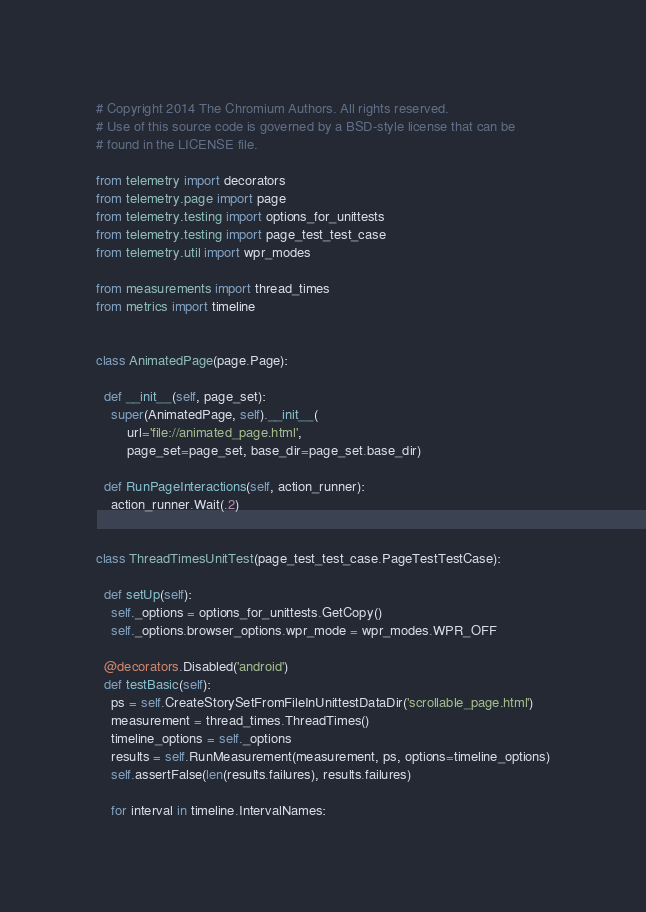Convert code to text. <code><loc_0><loc_0><loc_500><loc_500><_Python_># Copyright 2014 The Chromium Authors. All rights reserved.
# Use of this source code is governed by a BSD-style license that can be
# found in the LICENSE file.

from telemetry import decorators
from telemetry.page import page
from telemetry.testing import options_for_unittests
from telemetry.testing import page_test_test_case
from telemetry.util import wpr_modes

from measurements import thread_times
from metrics import timeline


class AnimatedPage(page.Page):

  def __init__(self, page_set):
    super(AnimatedPage, self).__init__(
        url='file://animated_page.html',
        page_set=page_set, base_dir=page_set.base_dir)

  def RunPageInteractions(self, action_runner):
    action_runner.Wait(.2)


class ThreadTimesUnitTest(page_test_test_case.PageTestTestCase):

  def setUp(self):
    self._options = options_for_unittests.GetCopy()
    self._options.browser_options.wpr_mode = wpr_modes.WPR_OFF

  @decorators.Disabled('android')
  def testBasic(self):
    ps = self.CreateStorySetFromFileInUnittestDataDir('scrollable_page.html')
    measurement = thread_times.ThreadTimes()
    timeline_options = self._options
    results = self.RunMeasurement(measurement, ps, options=timeline_options)
    self.assertFalse(len(results.failures), results.failures)

    for interval in timeline.IntervalNames:</code> 